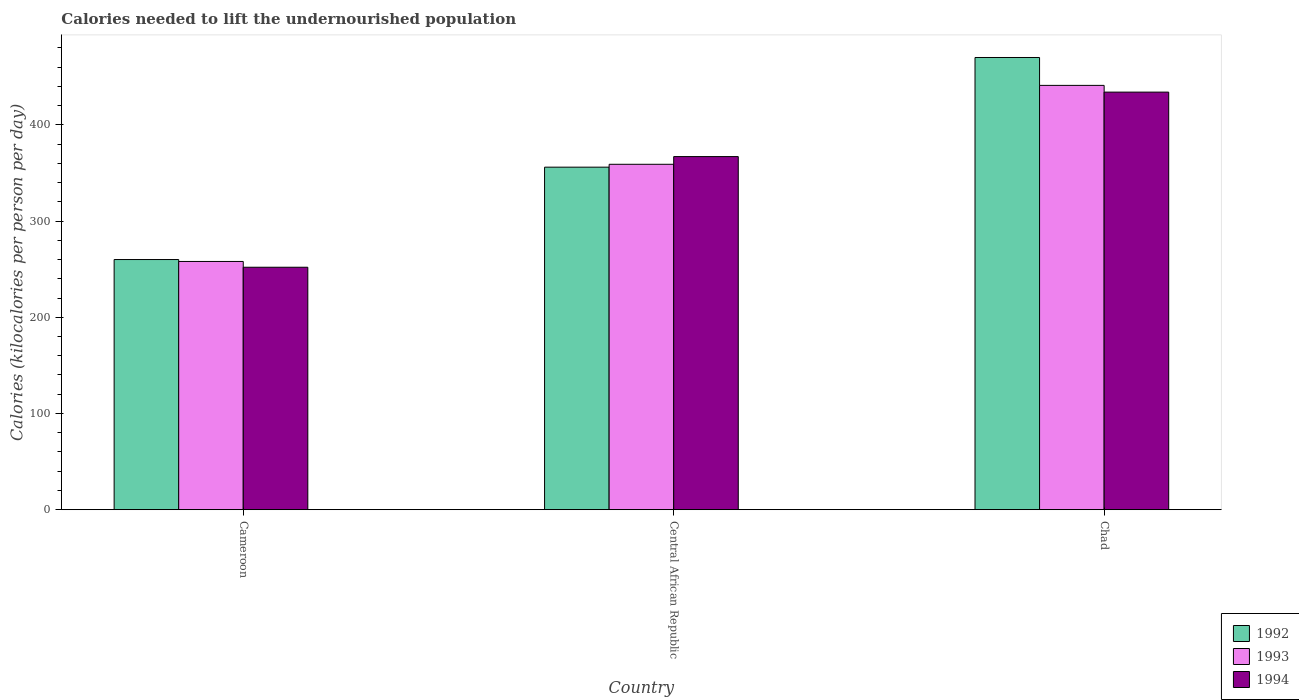Are the number of bars per tick equal to the number of legend labels?
Provide a short and direct response. Yes. Are the number of bars on each tick of the X-axis equal?
Your answer should be very brief. Yes. How many bars are there on the 1st tick from the left?
Your response must be concise. 3. How many bars are there on the 1st tick from the right?
Give a very brief answer. 3. What is the label of the 2nd group of bars from the left?
Offer a terse response. Central African Republic. In how many cases, is the number of bars for a given country not equal to the number of legend labels?
Provide a short and direct response. 0. What is the total calories needed to lift the undernourished population in 1994 in Chad?
Provide a short and direct response. 434. Across all countries, what is the maximum total calories needed to lift the undernourished population in 1993?
Your answer should be compact. 441. Across all countries, what is the minimum total calories needed to lift the undernourished population in 1992?
Offer a terse response. 260. In which country was the total calories needed to lift the undernourished population in 1994 maximum?
Offer a terse response. Chad. In which country was the total calories needed to lift the undernourished population in 1993 minimum?
Your response must be concise. Cameroon. What is the total total calories needed to lift the undernourished population in 1993 in the graph?
Give a very brief answer. 1058. What is the difference between the total calories needed to lift the undernourished population in 1992 in Central African Republic and that in Chad?
Keep it short and to the point. -114. What is the difference between the total calories needed to lift the undernourished population in 1993 in Cameroon and the total calories needed to lift the undernourished population in 1992 in Central African Republic?
Provide a succinct answer. -98. What is the average total calories needed to lift the undernourished population in 1992 per country?
Your answer should be compact. 362. What is the difference between the total calories needed to lift the undernourished population of/in 1993 and total calories needed to lift the undernourished population of/in 1992 in Chad?
Offer a very short reply. -29. In how many countries, is the total calories needed to lift the undernourished population in 1994 greater than 180 kilocalories?
Provide a short and direct response. 3. What is the ratio of the total calories needed to lift the undernourished population in 1993 in Cameroon to that in Central African Republic?
Offer a terse response. 0.72. Is the total calories needed to lift the undernourished population in 1992 in Cameroon less than that in Central African Republic?
Your response must be concise. Yes. What is the difference between the highest and the second highest total calories needed to lift the undernourished population in 1994?
Your answer should be very brief. 182. What is the difference between the highest and the lowest total calories needed to lift the undernourished population in 1993?
Provide a succinct answer. 183. What does the 2nd bar from the right in Cameroon represents?
Keep it short and to the point. 1993. Is it the case that in every country, the sum of the total calories needed to lift the undernourished population in 1993 and total calories needed to lift the undernourished population in 1992 is greater than the total calories needed to lift the undernourished population in 1994?
Your response must be concise. Yes. Are all the bars in the graph horizontal?
Your response must be concise. No. How many countries are there in the graph?
Offer a very short reply. 3. What is the difference between two consecutive major ticks on the Y-axis?
Your response must be concise. 100. Are the values on the major ticks of Y-axis written in scientific E-notation?
Your answer should be compact. No. Does the graph contain any zero values?
Your answer should be compact. No. Does the graph contain grids?
Offer a very short reply. No. Where does the legend appear in the graph?
Provide a succinct answer. Bottom right. How many legend labels are there?
Ensure brevity in your answer.  3. How are the legend labels stacked?
Your answer should be compact. Vertical. What is the title of the graph?
Provide a short and direct response. Calories needed to lift the undernourished population. Does "2002" appear as one of the legend labels in the graph?
Offer a terse response. No. What is the label or title of the X-axis?
Ensure brevity in your answer.  Country. What is the label or title of the Y-axis?
Your answer should be very brief. Calories (kilocalories per person per day). What is the Calories (kilocalories per person per day) in 1992 in Cameroon?
Give a very brief answer. 260. What is the Calories (kilocalories per person per day) in 1993 in Cameroon?
Offer a very short reply. 258. What is the Calories (kilocalories per person per day) of 1994 in Cameroon?
Offer a terse response. 252. What is the Calories (kilocalories per person per day) of 1992 in Central African Republic?
Your response must be concise. 356. What is the Calories (kilocalories per person per day) of 1993 in Central African Republic?
Offer a very short reply. 359. What is the Calories (kilocalories per person per day) in 1994 in Central African Republic?
Give a very brief answer. 367. What is the Calories (kilocalories per person per day) of 1992 in Chad?
Give a very brief answer. 470. What is the Calories (kilocalories per person per day) in 1993 in Chad?
Ensure brevity in your answer.  441. What is the Calories (kilocalories per person per day) in 1994 in Chad?
Ensure brevity in your answer.  434. Across all countries, what is the maximum Calories (kilocalories per person per day) in 1992?
Ensure brevity in your answer.  470. Across all countries, what is the maximum Calories (kilocalories per person per day) in 1993?
Keep it short and to the point. 441. Across all countries, what is the maximum Calories (kilocalories per person per day) of 1994?
Your response must be concise. 434. Across all countries, what is the minimum Calories (kilocalories per person per day) of 1992?
Offer a very short reply. 260. Across all countries, what is the minimum Calories (kilocalories per person per day) of 1993?
Provide a short and direct response. 258. Across all countries, what is the minimum Calories (kilocalories per person per day) in 1994?
Offer a terse response. 252. What is the total Calories (kilocalories per person per day) of 1992 in the graph?
Ensure brevity in your answer.  1086. What is the total Calories (kilocalories per person per day) of 1993 in the graph?
Your answer should be very brief. 1058. What is the total Calories (kilocalories per person per day) in 1994 in the graph?
Make the answer very short. 1053. What is the difference between the Calories (kilocalories per person per day) in 1992 in Cameroon and that in Central African Republic?
Your answer should be very brief. -96. What is the difference between the Calories (kilocalories per person per day) in 1993 in Cameroon and that in Central African Republic?
Make the answer very short. -101. What is the difference between the Calories (kilocalories per person per day) of 1994 in Cameroon and that in Central African Republic?
Make the answer very short. -115. What is the difference between the Calories (kilocalories per person per day) of 1992 in Cameroon and that in Chad?
Keep it short and to the point. -210. What is the difference between the Calories (kilocalories per person per day) of 1993 in Cameroon and that in Chad?
Make the answer very short. -183. What is the difference between the Calories (kilocalories per person per day) in 1994 in Cameroon and that in Chad?
Make the answer very short. -182. What is the difference between the Calories (kilocalories per person per day) of 1992 in Central African Republic and that in Chad?
Make the answer very short. -114. What is the difference between the Calories (kilocalories per person per day) of 1993 in Central African Republic and that in Chad?
Your answer should be very brief. -82. What is the difference between the Calories (kilocalories per person per day) of 1994 in Central African Republic and that in Chad?
Provide a succinct answer. -67. What is the difference between the Calories (kilocalories per person per day) of 1992 in Cameroon and the Calories (kilocalories per person per day) of 1993 in Central African Republic?
Your answer should be very brief. -99. What is the difference between the Calories (kilocalories per person per day) in 1992 in Cameroon and the Calories (kilocalories per person per day) in 1994 in Central African Republic?
Keep it short and to the point. -107. What is the difference between the Calories (kilocalories per person per day) of 1993 in Cameroon and the Calories (kilocalories per person per day) of 1994 in Central African Republic?
Your response must be concise. -109. What is the difference between the Calories (kilocalories per person per day) in 1992 in Cameroon and the Calories (kilocalories per person per day) in 1993 in Chad?
Offer a terse response. -181. What is the difference between the Calories (kilocalories per person per day) in 1992 in Cameroon and the Calories (kilocalories per person per day) in 1994 in Chad?
Your response must be concise. -174. What is the difference between the Calories (kilocalories per person per day) in 1993 in Cameroon and the Calories (kilocalories per person per day) in 1994 in Chad?
Offer a terse response. -176. What is the difference between the Calories (kilocalories per person per day) in 1992 in Central African Republic and the Calories (kilocalories per person per day) in 1993 in Chad?
Your answer should be compact. -85. What is the difference between the Calories (kilocalories per person per day) of 1992 in Central African Republic and the Calories (kilocalories per person per day) of 1994 in Chad?
Offer a terse response. -78. What is the difference between the Calories (kilocalories per person per day) of 1993 in Central African Republic and the Calories (kilocalories per person per day) of 1994 in Chad?
Offer a very short reply. -75. What is the average Calories (kilocalories per person per day) in 1992 per country?
Offer a terse response. 362. What is the average Calories (kilocalories per person per day) in 1993 per country?
Make the answer very short. 352.67. What is the average Calories (kilocalories per person per day) in 1994 per country?
Provide a short and direct response. 351. What is the difference between the Calories (kilocalories per person per day) of 1992 and Calories (kilocalories per person per day) of 1993 in Cameroon?
Provide a succinct answer. 2. What is the difference between the Calories (kilocalories per person per day) in 1993 and Calories (kilocalories per person per day) in 1994 in Cameroon?
Offer a very short reply. 6. What is the difference between the Calories (kilocalories per person per day) in 1992 and Calories (kilocalories per person per day) in 1994 in Central African Republic?
Ensure brevity in your answer.  -11. What is the difference between the Calories (kilocalories per person per day) of 1993 and Calories (kilocalories per person per day) of 1994 in Central African Republic?
Make the answer very short. -8. What is the ratio of the Calories (kilocalories per person per day) of 1992 in Cameroon to that in Central African Republic?
Give a very brief answer. 0.73. What is the ratio of the Calories (kilocalories per person per day) in 1993 in Cameroon to that in Central African Republic?
Your response must be concise. 0.72. What is the ratio of the Calories (kilocalories per person per day) of 1994 in Cameroon to that in Central African Republic?
Your answer should be compact. 0.69. What is the ratio of the Calories (kilocalories per person per day) in 1992 in Cameroon to that in Chad?
Provide a short and direct response. 0.55. What is the ratio of the Calories (kilocalories per person per day) of 1993 in Cameroon to that in Chad?
Make the answer very short. 0.58. What is the ratio of the Calories (kilocalories per person per day) in 1994 in Cameroon to that in Chad?
Your response must be concise. 0.58. What is the ratio of the Calories (kilocalories per person per day) in 1992 in Central African Republic to that in Chad?
Provide a succinct answer. 0.76. What is the ratio of the Calories (kilocalories per person per day) of 1993 in Central African Republic to that in Chad?
Offer a terse response. 0.81. What is the ratio of the Calories (kilocalories per person per day) of 1994 in Central African Republic to that in Chad?
Keep it short and to the point. 0.85. What is the difference between the highest and the second highest Calories (kilocalories per person per day) of 1992?
Ensure brevity in your answer.  114. What is the difference between the highest and the second highest Calories (kilocalories per person per day) in 1993?
Make the answer very short. 82. What is the difference between the highest and the lowest Calories (kilocalories per person per day) of 1992?
Keep it short and to the point. 210. What is the difference between the highest and the lowest Calories (kilocalories per person per day) in 1993?
Offer a terse response. 183. What is the difference between the highest and the lowest Calories (kilocalories per person per day) of 1994?
Keep it short and to the point. 182. 